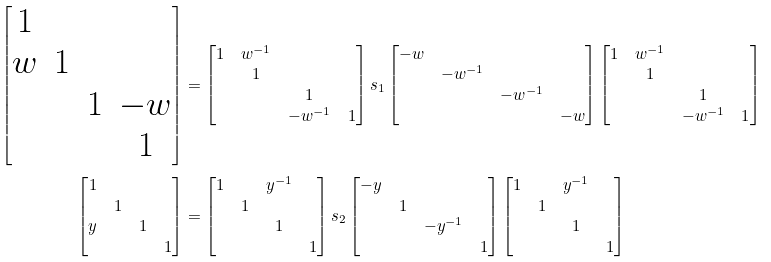<formula> <loc_0><loc_0><loc_500><loc_500>\begin{bmatrix} 1 \\ w & 1 \\ & & 1 & - w \\ & & & 1 \end{bmatrix} & = \begin{bmatrix} 1 & w ^ { - 1 } \\ & 1 \\ & & 1 \\ & & - w ^ { - 1 } & 1 \end{bmatrix} s _ { 1 } \begin{bmatrix} - w \\ & - w ^ { - 1 } \\ & & - w ^ { - 1 } \\ & & & - w \end{bmatrix} \begin{bmatrix} 1 & w ^ { - 1 } \\ & 1 \\ & & 1 \\ & & - w ^ { - 1 } & 1 \end{bmatrix} \\ \begin{bmatrix} 1 \\ & 1 \\ y & & 1 \\ & & & 1 \end{bmatrix} & = \begin{bmatrix} 1 & & y ^ { - 1 } \\ & 1 \\ & & 1 \\ & & & 1 \end{bmatrix} s _ { 2 } \begin{bmatrix} - y \\ & 1 \\ & & - y ^ { - 1 } \\ & & & 1 \end{bmatrix} \begin{bmatrix} 1 & & y ^ { - 1 } \\ & 1 \\ & & 1 \\ & & & 1 \end{bmatrix}</formula> 